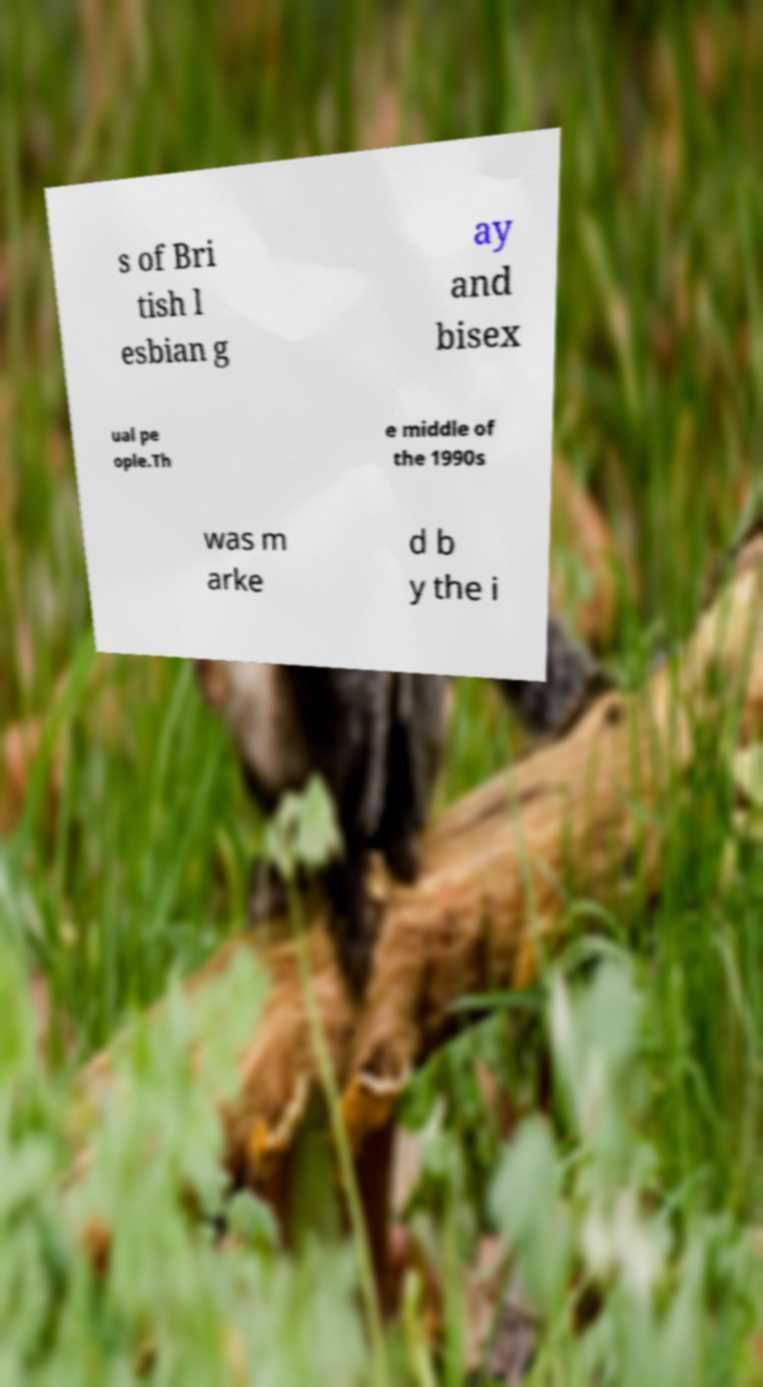Please read and relay the text visible in this image. What does it say? s of Bri tish l esbian g ay and bisex ual pe ople.Th e middle of the 1990s was m arke d b y the i 